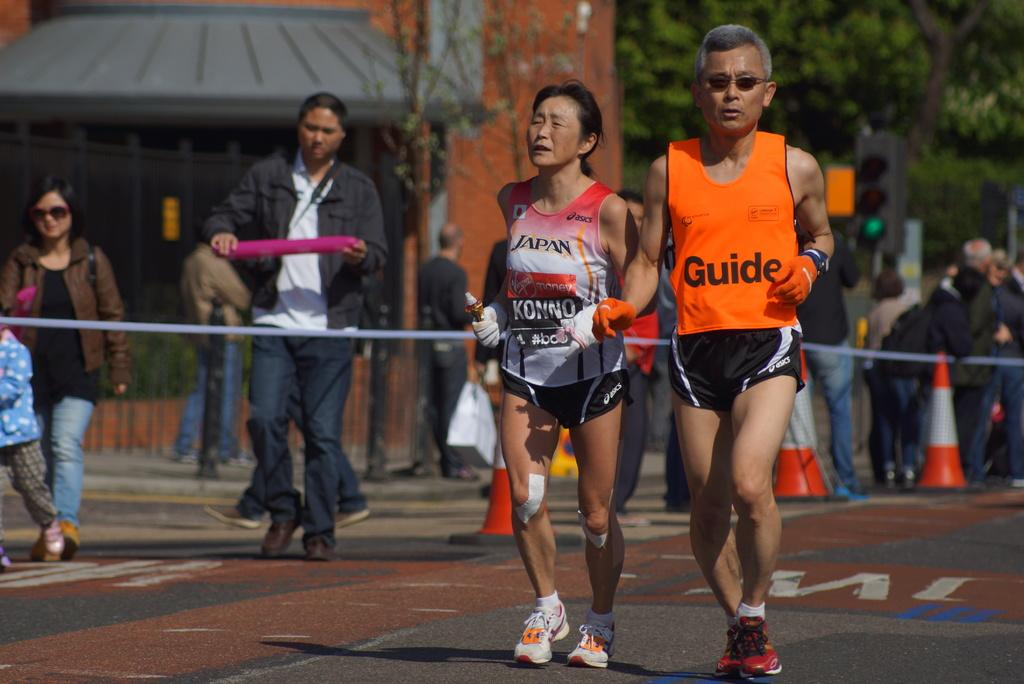<image>
Give a short and clear explanation of the subsequent image. The lady running in this race has Japan on her top. 